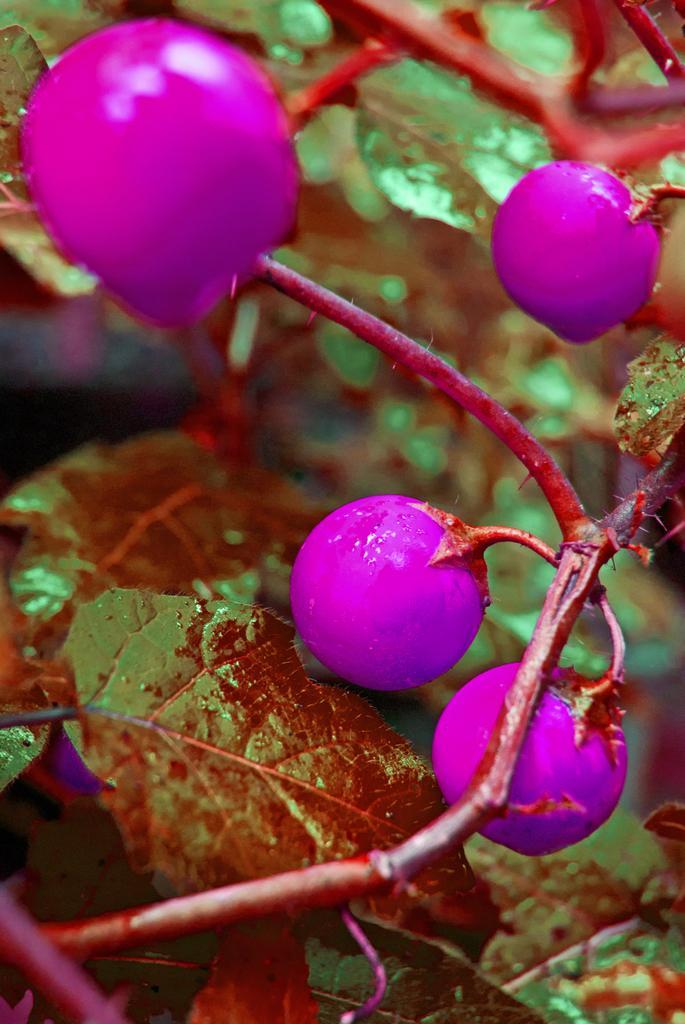Describe this image in one or two sentences. In this picture we can see branches with fruits and leaves and in the background it is blurry. 